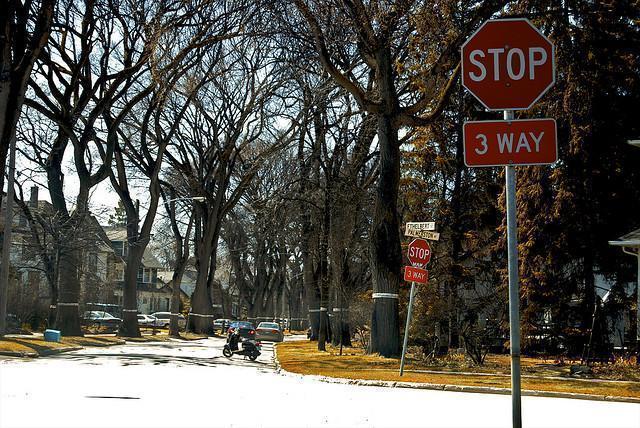How many ways are there on this stop sign?
Choose the right answer from the provided options to respond to the question.
Options: Two, three, four, one. Three. 